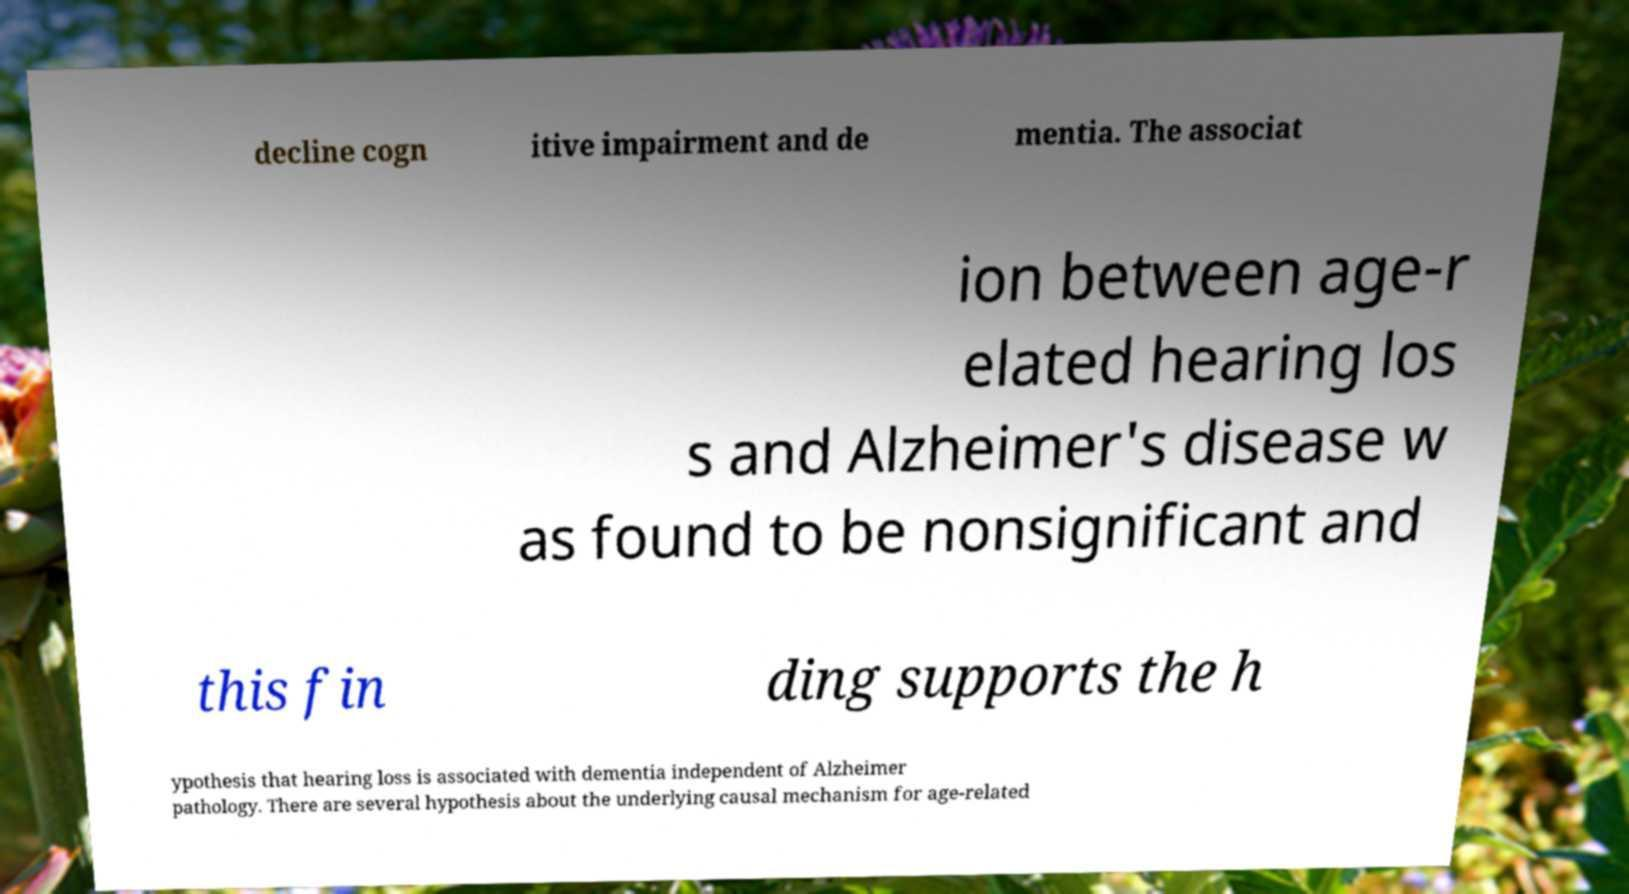Could you extract and type out the text from this image? decline cogn itive impairment and de mentia. The associat ion between age-r elated hearing los s and Alzheimer's disease w as found to be nonsignificant and this fin ding supports the h ypothesis that hearing loss is associated with dementia independent of Alzheimer pathology. There are several hypothesis about the underlying causal mechanism for age-related 